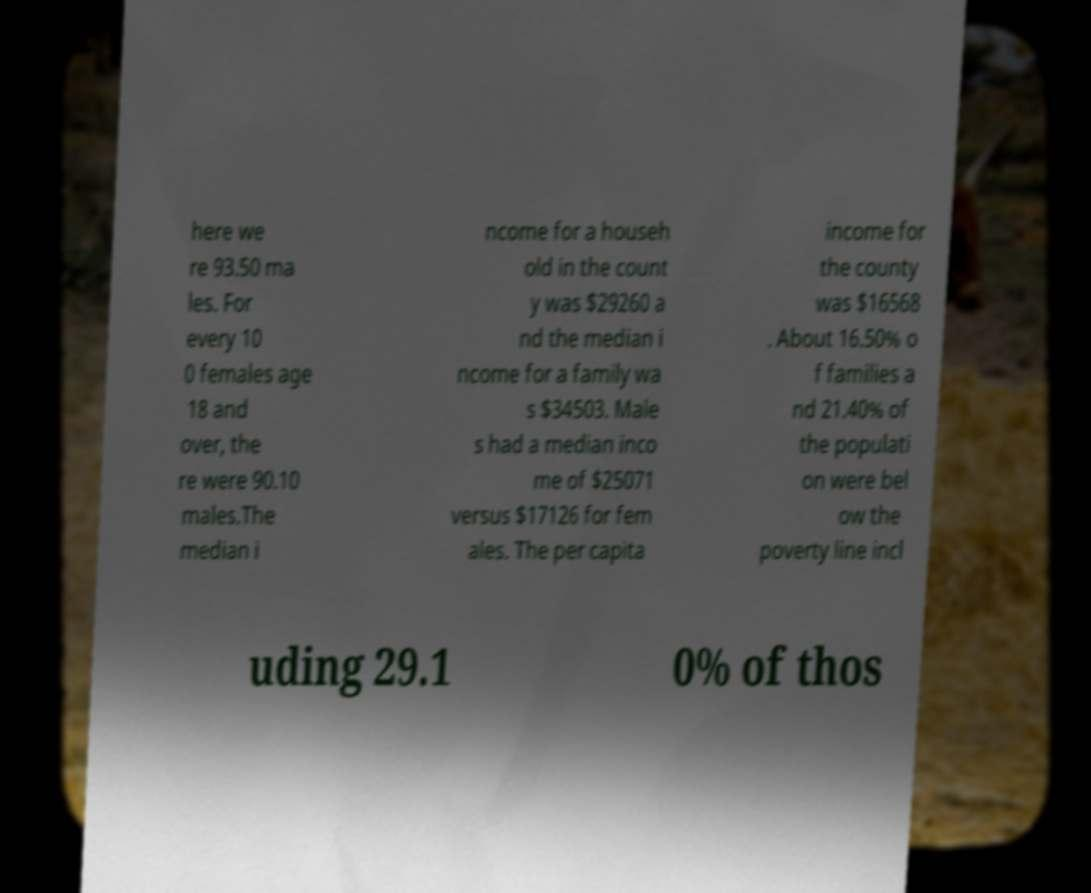There's text embedded in this image that I need extracted. Can you transcribe it verbatim? here we re 93.50 ma les. For every 10 0 females age 18 and over, the re were 90.10 males.The median i ncome for a househ old in the count y was $29260 a nd the median i ncome for a family wa s $34503. Male s had a median inco me of $25071 versus $17126 for fem ales. The per capita income for the county was $16568 . About 16.50% o f families a nd 21.40% of the populati on were bel ow the poverty line incl uding 29.1 0% of thos 